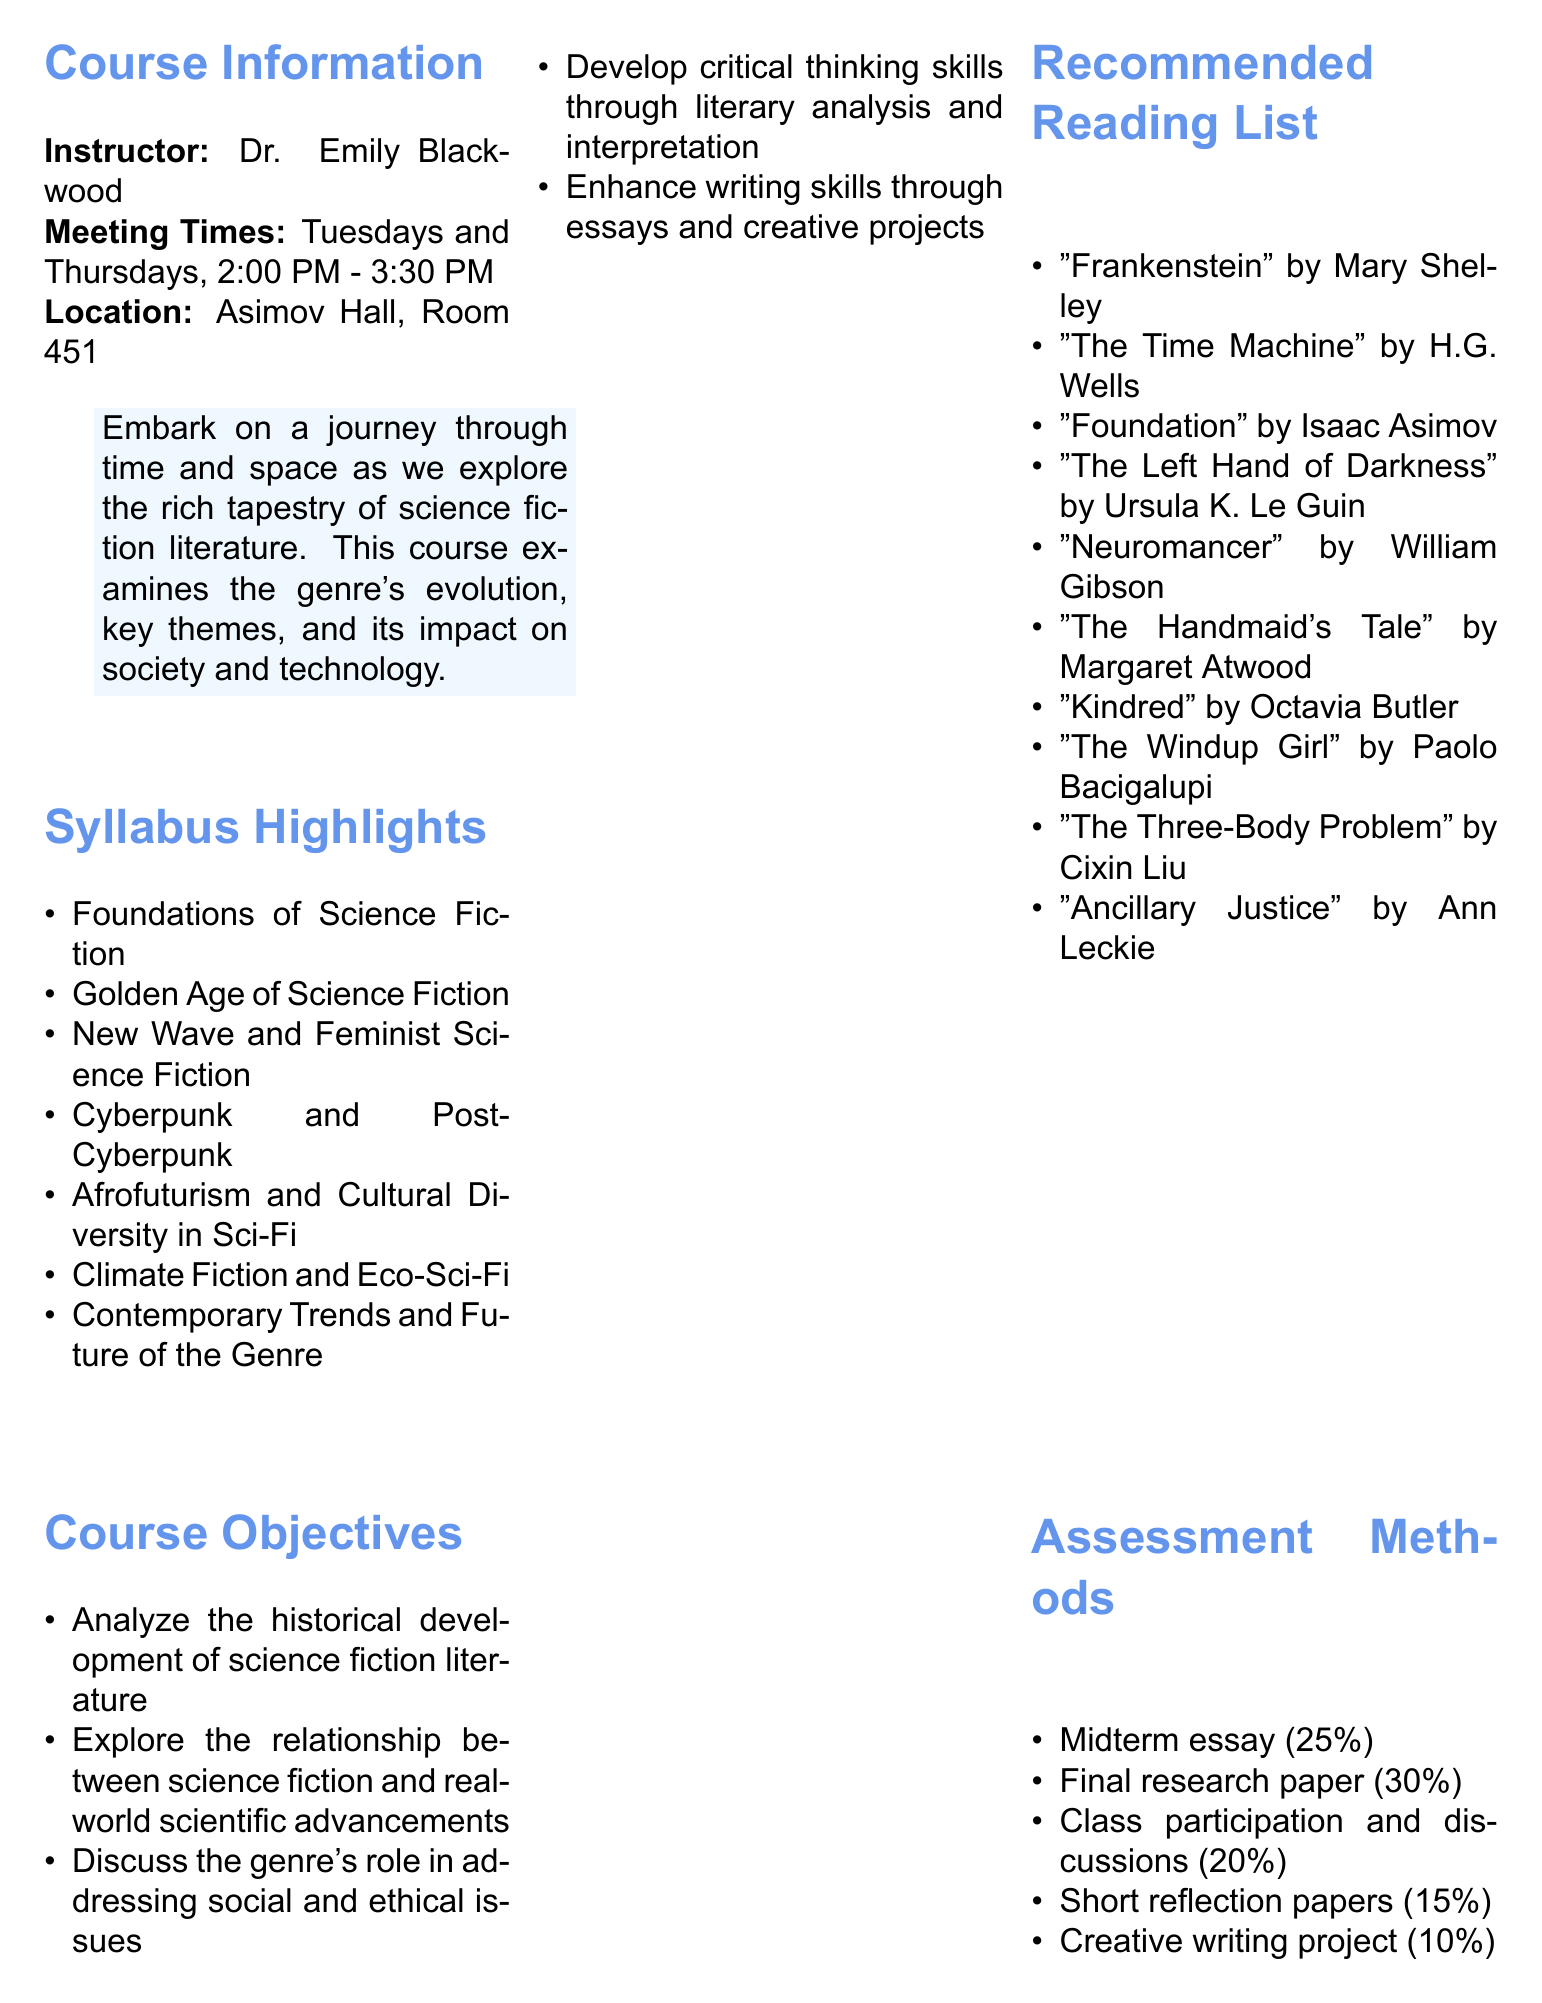What is the course code? The course code is explicitly stated in the brochure under course information.
Answer: ENG 305 Who is the instructor? The name of the instructor is clearly listed in the course information section.
Answer: Dr. Emily Blackwood When does the course meet? The meeting times for the course are mentioned in the course information section.
Answer: Tuesdays and Thursdays, 2:00 PM - 3:30 PM What is one focus area in Week 5-6? The syllabus highlights include various topics covered in the course, one being mentioned in the specified weeks.
Answer: New Wave and Feminist Science Fiction Which book is written by William Gibson? The recommended reading list includes works by various authors, one of whom is William Gibson.
Answer: Neuromancer How much is the midterm essay worth? The assessment methods section provides the weight of different evaluation components, including the midterm essay.
Answer: 25% What date is the author talk event? The document lists specific dates for events, including the guest lecture with N.K. Jemisin.
Answer: October 15, 2023 Where is the Science Fiction Writing Workshop held? The location for the Science Fiction Writing Workshop event is specified in the document.
Answer: Creative Writing Center 